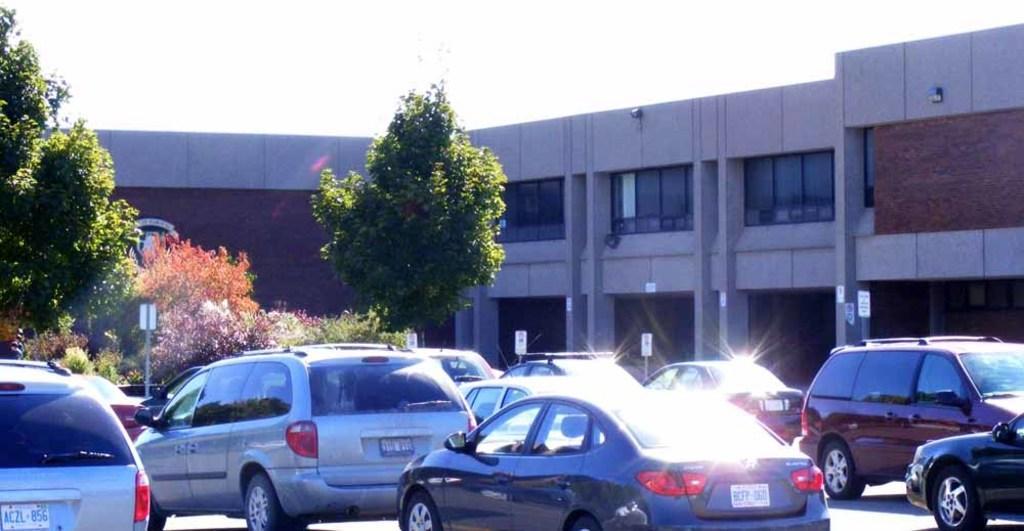Describe this image in one or two sentences. These are the cars moving on the road, on the left side there are trees and on the right side it's a building. 